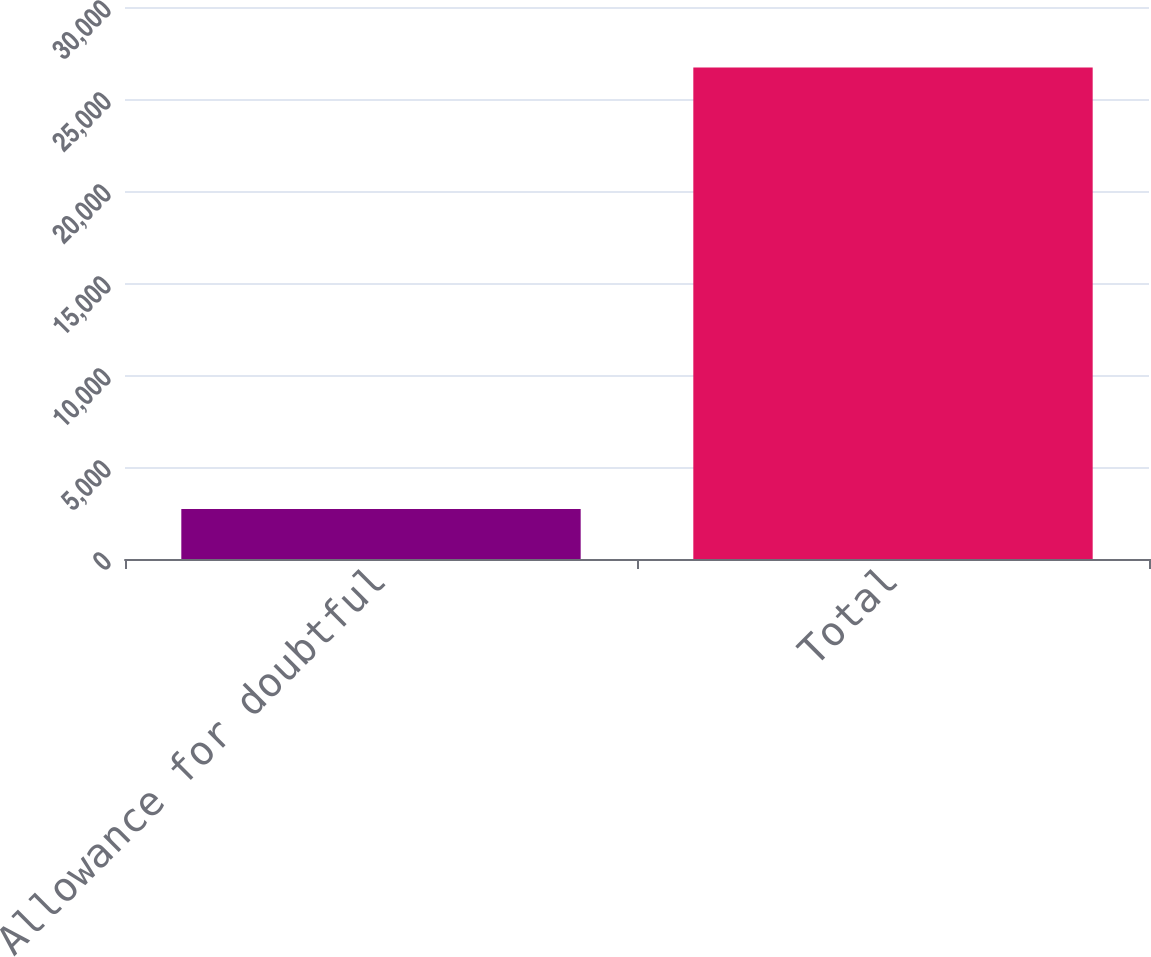Convert chart. <chart><loc_0><loc_0><loc_500><loc_500><bar_chart><fcel>Allowance for doubtful<fcel>Total<nl><fcel>2724<fcel>26718<nl></chart> 